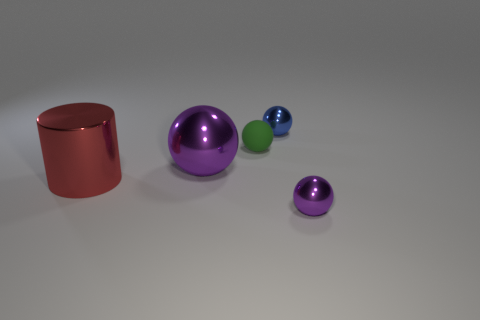Are there any other things that are the same material as the tiny green object?
Keep it short and to the point. No. The tiny rubber ball is what color?
Provide a succinct answer. Green. Are there any other spheres of the same color as the matte sphere?
Ensure brevity in your answer.  No. There is a small ball that is the same color as the big sphere; what is it made of?
Your response must be concise. Metal. How many rubber balls have the same color as the rubber thing?
Offer a terse response. 0. Is there a tiny purple shiny thing of the same shape as the big purple thing?
Offer a terse response. Yes. Is the number of green things less than the number of cyan cylinders?
Provide a succinct answer. No. Is the size of the metal thing on the left side of the big purple metal object the same as the sphere in front of the big cylinder?
Your answer should be compact. No. How many things are either purple metal things or cyan rubber balls?
Your answer should be very brief. 2. How big is the metallic ball that is on the left side of the green object?
Provide a short and direct response. Large. 